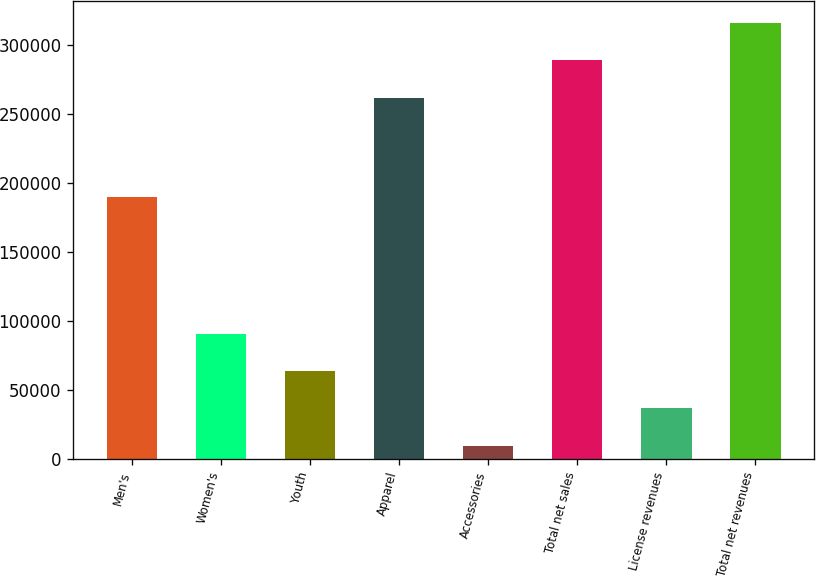<chart> <loc_0><loc_0><loc_500><loc_500><bar_chart><fcel>Men's<fcel>Women's<fcel>Youth<fcel>Apparel<fcel>Accessories<fcel>Total net sales<fcel>License revenues<fcel>Total net revenues<nl><fcel>189596<fcel>90902.2<fcel>63737.8<fcel>261880<fcel>9409<fcel>289044<fcel>36573.4<fcel>316209<nl></chart> 